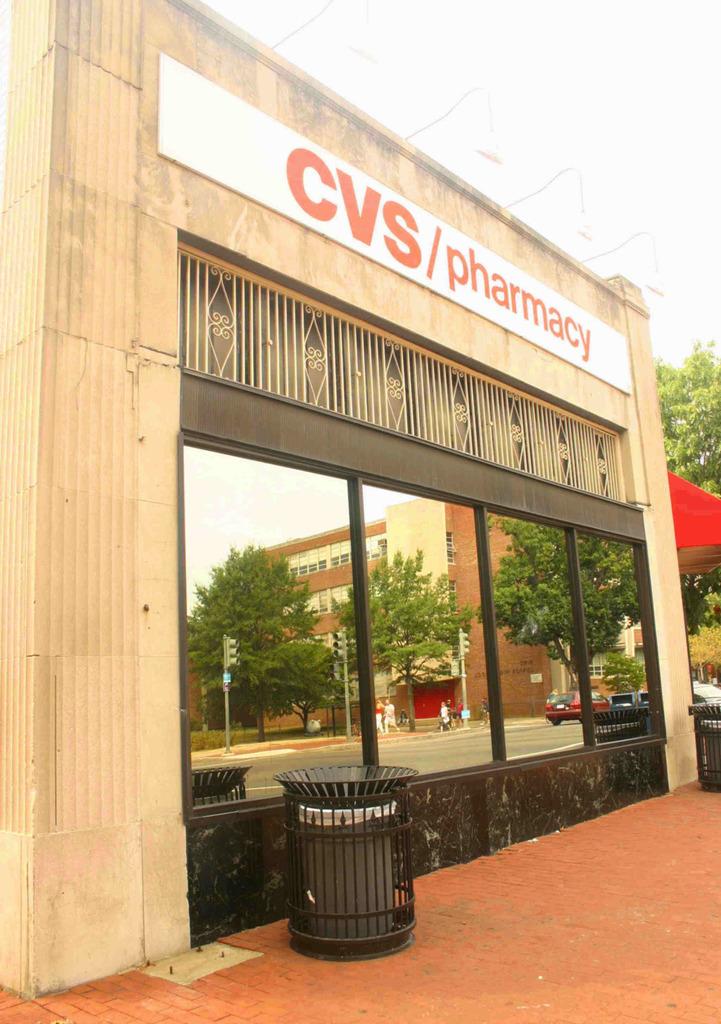What store is listed on the sign?
Give a very brief answer. Cvs. 